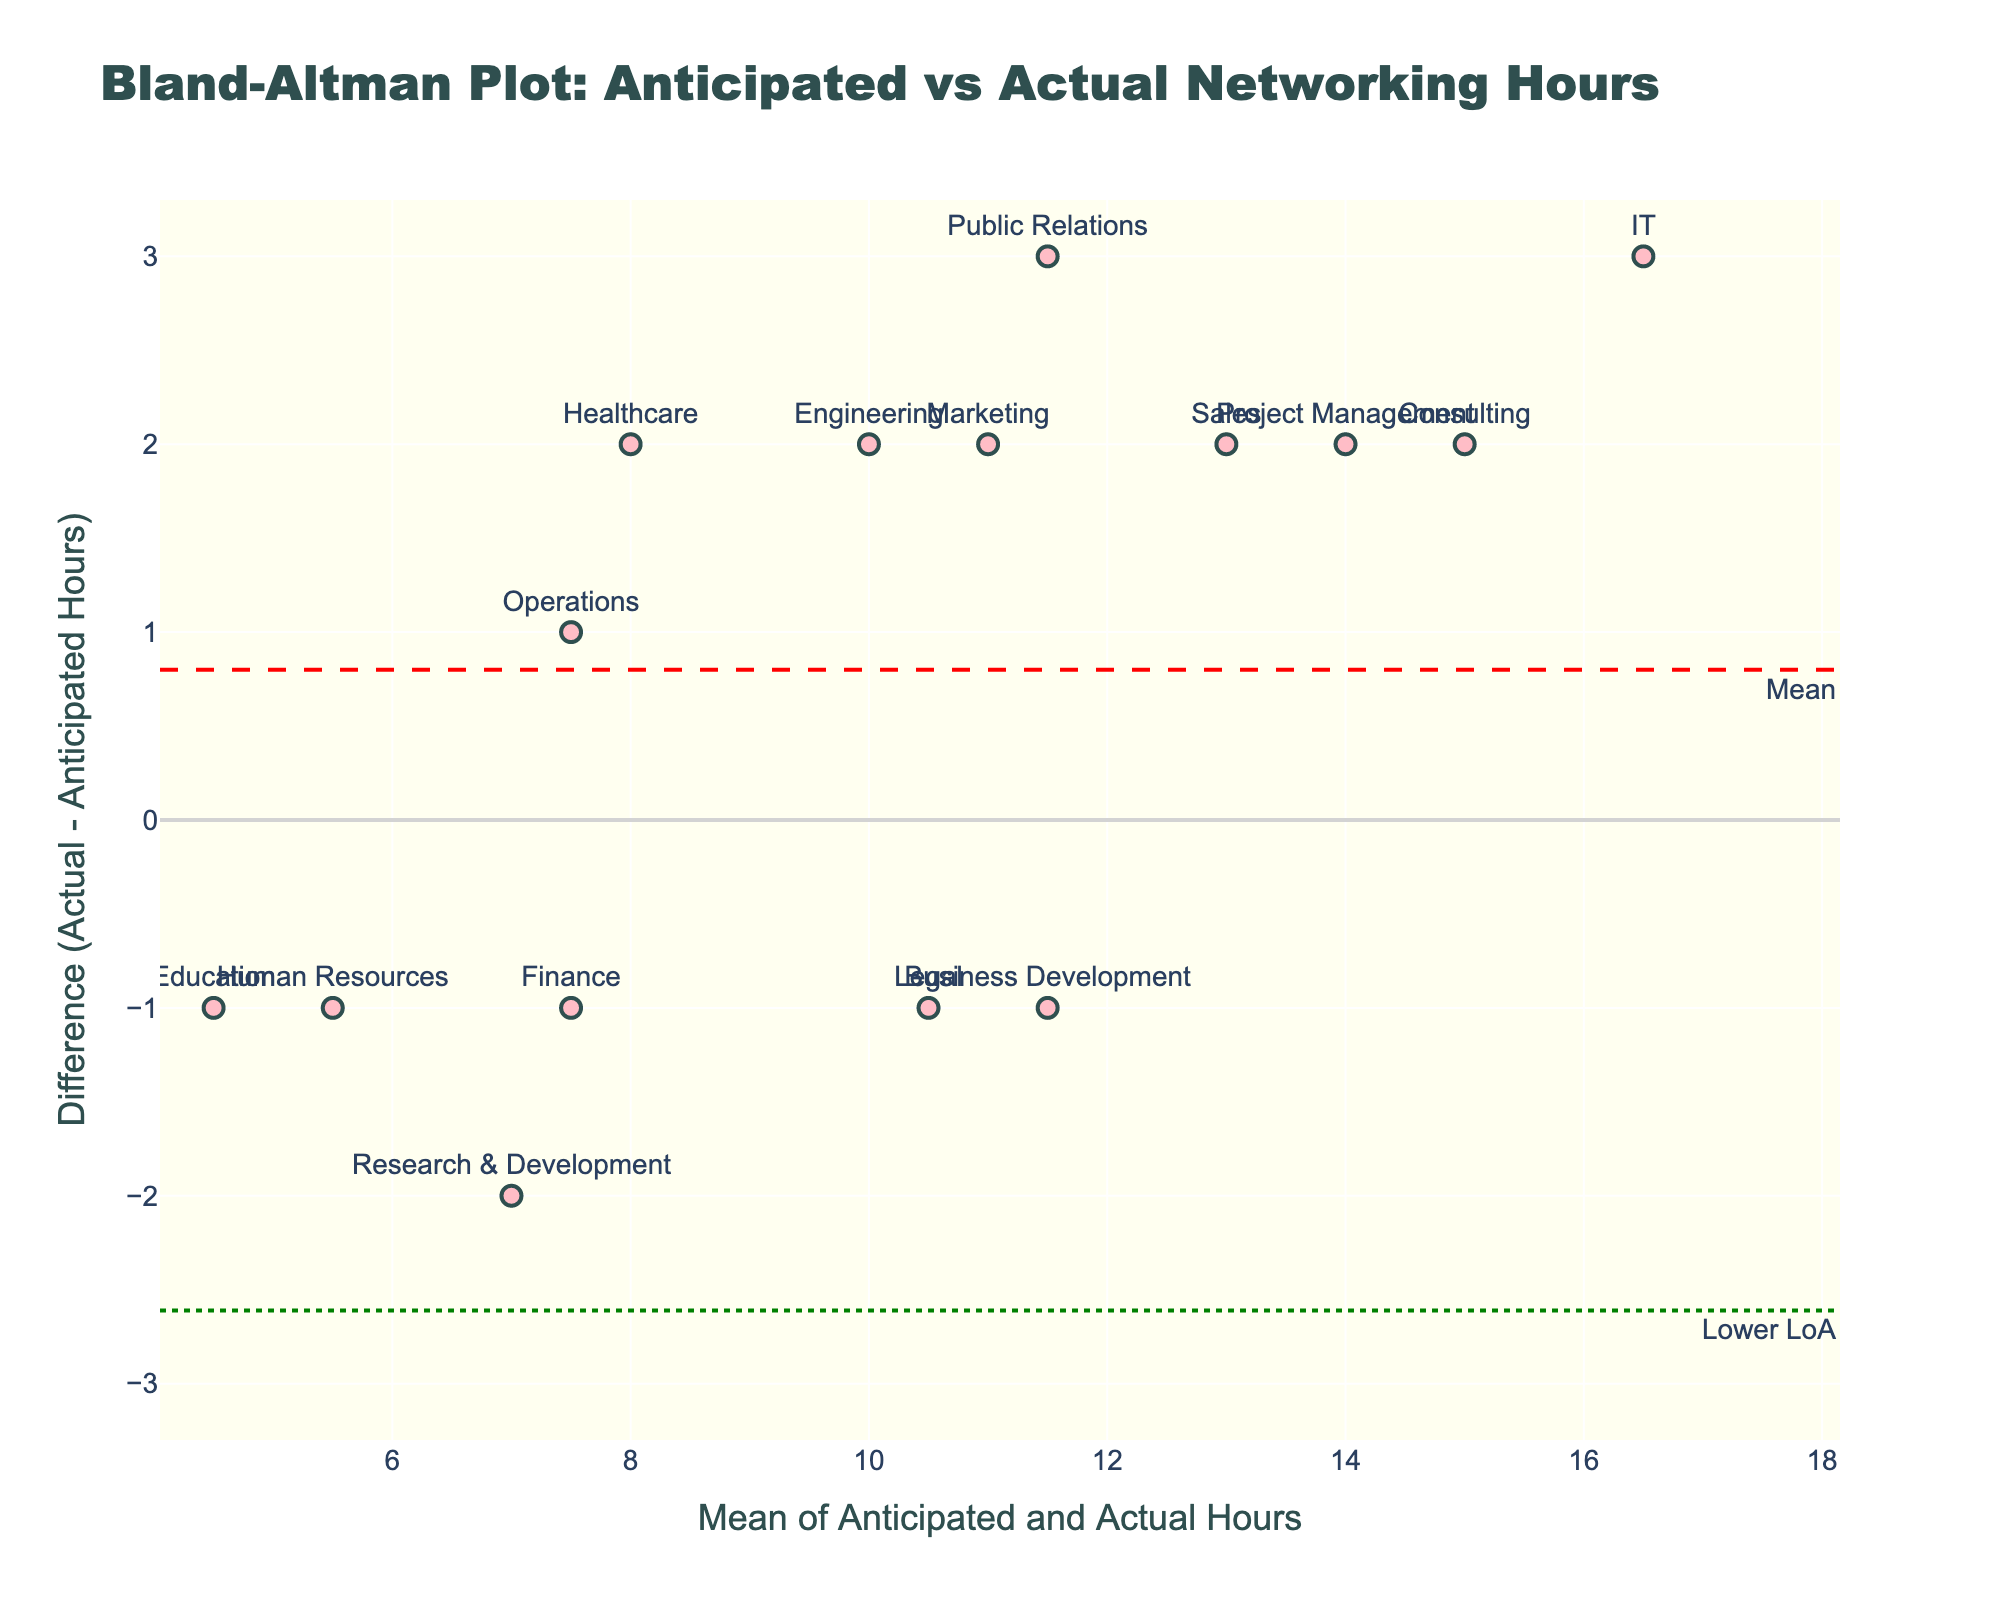What is the title of the plot? The title of the plot is usually displayed at the top of the figure. It provides a short description of what the plot represents. In this case, the title is clearly given.
Answer: Bland-Altman Plot: Anticipated vs Actual Networking Hours What does the x-axis represent? The x-axis typically shows the mean of anticipated and actual hours. From the plot, we can see that it ranges from the minimum to maximum mean values.
Answer: Mean of Anticipated and Actual Hours What does the y-axis represent? The y-axis usually represents the difference between actual and anticipated hours. This is inferred from how Bland-Altman plots are structured and the labels provided on the axis.
Answer: Difference (Actual - Anticipated Hours) How many sectors are represented in the plot? Each sector is represented by a marker in the plot, and by counting the labels or markers, we can determine the number of sectors.
Answer: 15 Which sector shows the largest positive difference between actual and anticipated hours? The largest positive difference on the y-axis will correspond to the sector with the highest marker above the zero line. Here, Public Relations has the highest positive difference.
Answer: Public Relations Which sector shows the largest negative difference between actual and anticipated hours? The largest negative difference on the y-axis will correspond to the sector with the lowest marker below the zero line. Human Resources is the sector with the largest negative difference.
Answer: Human Resources What are the limits of agreement in the plot? The limits of agreement are typically shown as dotted lines on the plot, one above and one below the mean difference line. These values can be read off from where the horizontal dotted lines intersect the y-axis.
Answer: Upper: 3.397, Lower: -4.064 Which sectors have actual hours less than anticipated hours? Sectors with markers below the zero difference line have actual hours less than anticipated hours. These sectors include Human Resources, Business Development, Finance, Research & Development, Legal, and Education.
Answer: Human Resources, Business Development, Finance, Research & Development, Legal, Education What is the mean difference between actual and anticipated hours? The mean difference is usually shown as a dashed line on the plot. The y-coordinate of this line indicates the mean difference value.
Answer: -0.33 